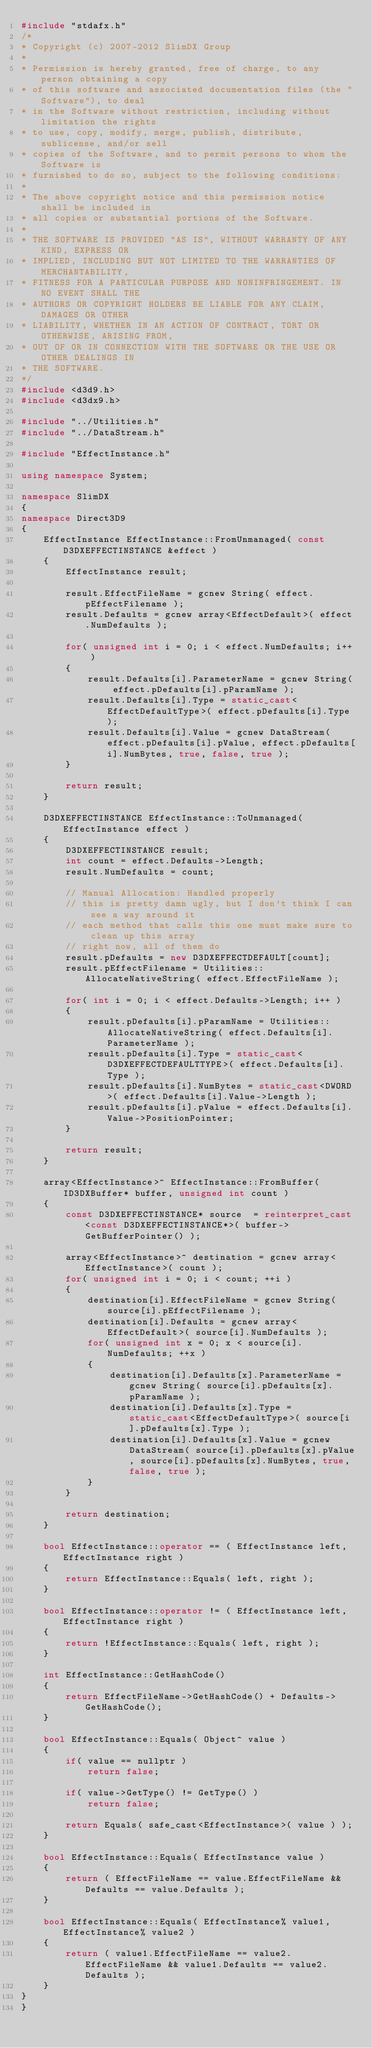Convert code to text. <code><loc_0><loc_0><loc_500><loc_500><_C++_>#include "stdafx.h"
/*
* Copyright (c) 2007-2012 SlimDX Group
* 
* Permission is hereby granted, free of charge, to any person obtaining a copy
* of this software and associated documentation files (the "Software"), to deal
* in the Software without restriction, including without limitation the rights
* to use, copy, modify, merge, publish, distribute, sublicense, and/or sell
* copies of the Software, and to permit persons to whom the Software is
* furnished to do so, subject to the following conditions:
* 
* The above copyright notice and this permission notice shall be included in
* all copies or substantial portions of the Software.
* 
* THE SOFTWARE IS PROVIDED "AS IS", WITHOUT WARRANTY OF ANY KIND, EXPRESS OR
* IMPLIED, INCLUDING BUT NOT LIMITED TO THE WARRANTIES OF MERCHANTABILITY,
* FITNESS FOR A PARTICULAR PURPOSE AND NONINFRINGEMENT. IN NO EVENT SHALL THE
* AUTHORS OR COPYRIGHT HOLDERS BE LIABLE FOR ANY CLAIM, DAMAGES OR OTHER
* LIABILITY, WHETHER IN AN ACTION OF CONTRACT, TORT OR OTHERWISE, ARISING FROM,
* OUT OF OR IN CONNECTION WITH THE SOFTWARE OR THE USE OR OTHER DEALINGS IN
* THE SOFTWARE.
*/
#include <d3d9.h>
#include <d3dx9.h>

#include "../Utilities.h"
#include "../DataStream.h"

#include "EffectInstance.h"

using namespace System;

namespace SlimDX
{
namespace Direct3D9
{
	EffectInstance EffectInstance::FromUnmanaged( const D3DXEFFECTINSTANCE &effect )
	{
		EffectInstance result;

		result.EffectFileName = gcnew String( effect.pEffectFilename );
		result.Defaults = gcnew array<EffectDefault>( effect.NumDefaults );

		for( unsigned int i = 0; i < effect.NumDefaults; i++ )
		{
			result.Defaults[i].ParameterName = gcnew String( effect.pDefaults[i].pParamName );
			result.Defaults[i].Type = static_cast<EffectDefaultType>( effect.pDefaults[i].Type );
			result.Defaults[i].Value = gcnew DataStream( effect.pDefaults[i].pValue, effect.pDefaults[i].NumBytes, true, false, true );
		}

		return result;
	}

	D3DXEFFECTINSTANCE EffectInstance::ToUnmanaged( EffectInstance effect )
	{
		D3DXEFFECTINSTANCE result;
		int count = effect.Defaults->Length;
		result.NumDefaults = count;

		// Manual Allocation: Handled properly
		// this is pretty damn ugly, but I don't think I can see a way around it
		// each method that calls this one must make sure to clean up this array
		// right now, all of them do
		result.pDefaults = new D3DXEFFECTDEFAULT[count];
		result.pEffectFilename = Utilities::AllocateNativeString( effect.EffectFileName );

		for( int i = 0; i < effect.Defaults->Length; i++ )
		{
			result.pDefaults[i].pParamName = Utilities::AllocateNativeString( effect.Defaults[i].ParameterName );
			result.pDefaults[i].Type = static_cast<D3DXEFFECTDEFAULTTYPE>( effect.Defaults[i].Type );
			result.pDefaults[i].NumBytes = static_cast<DWORD>( effect.Defaults[i].Value->Length );
			result.pDefaults[i].pValue = effect.Defaults[i].Value->PositionPointer;
		}

		return result;
	}

	array<EffectInstance>^ EffectInstance::FromBuffer( ID3DXBuffer* buffer, unsigned int count )
	{
		const D3DXEFFECTINSTANCE* source  = reinterpret_cast<const D3DXEFFECTINSTANCE*>( buffer->GetBufferPointer() );

		array<EffectInstance>^ destination = gcnew array<EffectInstance>( count );
		for( unsigned int i = 0; i < count; ++i )
		{
			destination[i].EffectFileName = gcnew String( source[i].pEffectFilename );
			destination[i].Defaults = gcnew array<EffectDefault>( source[i].NumDefaults );
			for( unsigned int x = 0; x < source[i].NumDefaults; ++x )
			{
				destination[i].Defaults[x].ParameterName = gcnew String( source[i].pDefaults[x].pParamName );
				destination[i].Defaults[x].Type = static_cast<EffectDefaultType>( source[i].pDefaults[x].Type );
				destination[i].Defaults[x].Value = gcnew DataStream( source[i].pDefaults[x].pValue, source[i].pDefaults[x].NumBytes, true, false, true );
			}
		}

		return destination;
	}

	bool EffectInstance::operator == ( EffectInstance left, EffectInstance right )
	{
		return EffectInstance::Equals( left, right );
	}

	bool EffectInstance::operator != ( EffectInstance left, EffectInstance right )
	{
		return !EffectInstance::Equals( left, right );
	}

	int EffectInstance::GetHashCode()
	{
		return EffectFileName->GetHashCode() + Defaults->GetHashCode();
	}

	bool EffectInstance::Equals( Object^ value )
	{
		if( value == nullptr )
			return false;

		if( value->GetType() != GetType() )
			return false;

		return Equals( safe_cast<EffectInstance>( value ) );
	}

	bool EffectInstance::Equals( EffectInstance value )
	{
		return ( EffectFileName == value.EffectFileName && Defaults == value.Defaults );
	}

	bool EffectInstance::Equals( EffectInstance% value1, EffectInstance% value2 )
	{
		return ( value1.EffectFileName == value2.EffectFileName && value1.Defaults == value2.Defaults );
	}
}
}</code> 